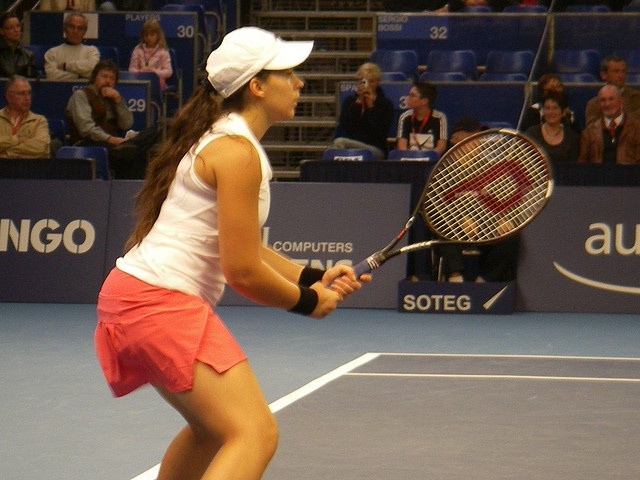Describe the objects in this image and their specific colors. I can see people in black, beige, red, orange, and maroon tones, tennis racket in black, maroon, and gray tones, people in black, maroon, and gray tones, people in black, maroon, and gray tones, and people in black, maroon, and brown tones in this image. 